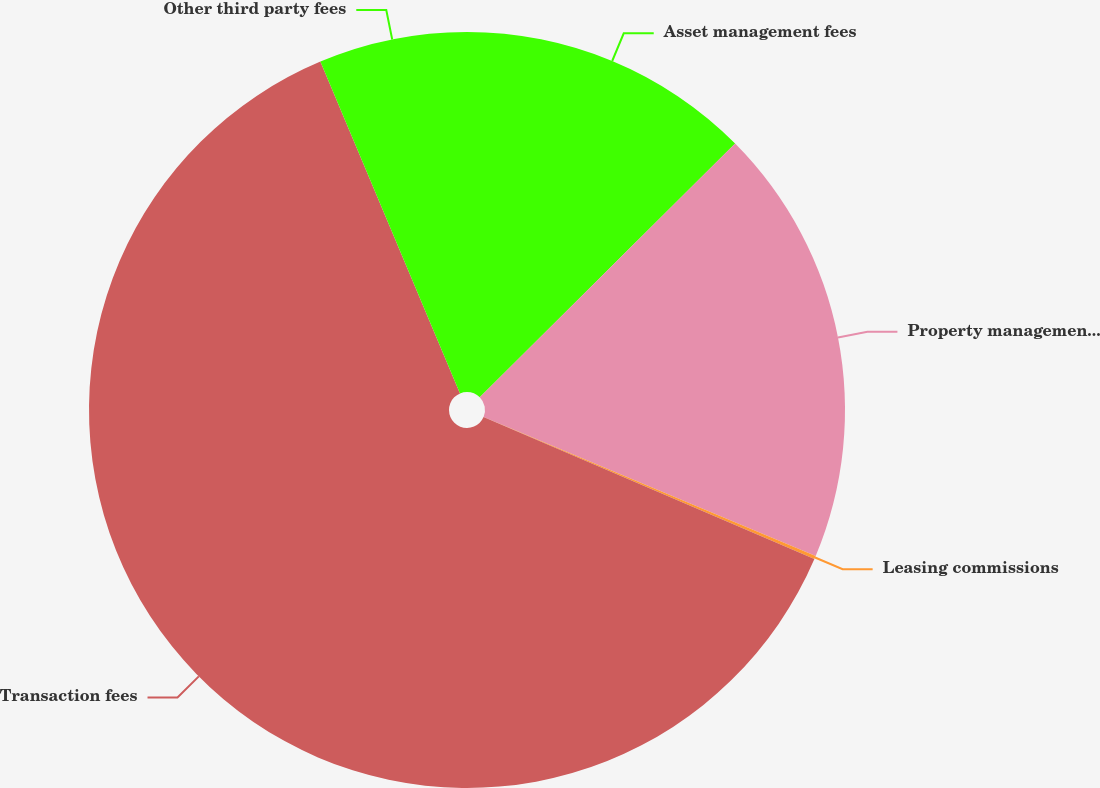Convert chart. <chart><loc_0><loc_0><loc_500><loc_500><pie_chart><fcel>Asset management fees<fcel>Property management fees<fcel>Leasing commissions<fcel>Transaction fees<fcel>Other third party fees<nl><fcel>12.55%<fcel>18.76%<fcel>0.14%<fcel>62.21%<fcel>6.34%<nl></chart> 